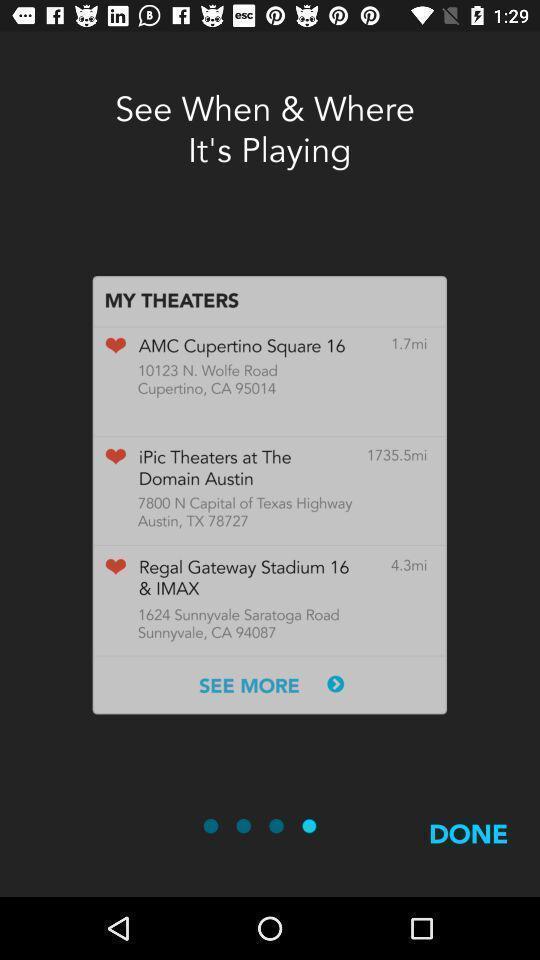Summarize the main components in this picture. Popup showing options to select. 